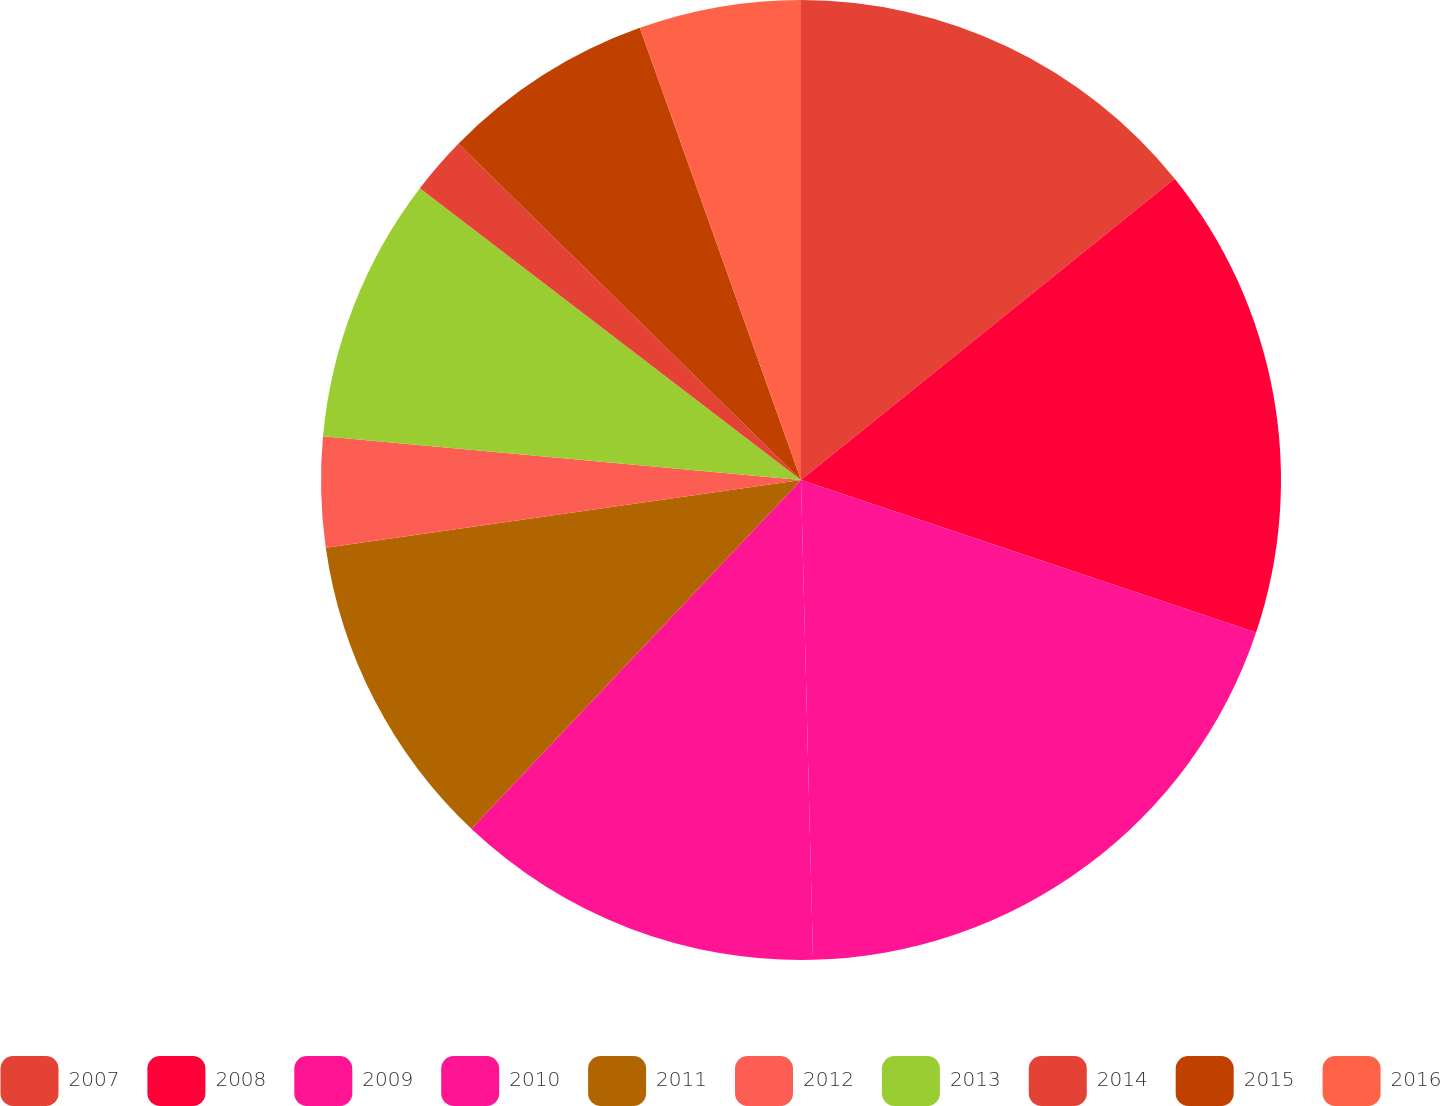<chart> <loc_0><loc_0><loc_500><loc_500><pie_chart><fcel>2007<fcel>2008<fcel>2009<fcel>2010<fcel>2011<fcel>2012<fcel>2013<fcel>2014<fcel>2015<fcel>2016<nl><fcel>14.2%<fcel>15.95%<fcel>19.45%<fcel>12.45%<fcel>10.7%<fcel>3.7%<fcel>8.95%<fcel>1.95%<fcel>7.2%<fcel>5.45%<nl></chart> 